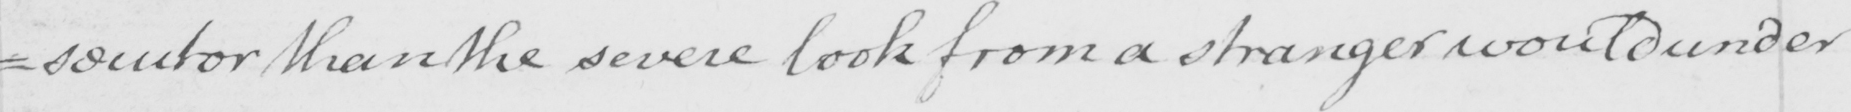What does this handwritten line say? =secutor than the severe look from a stranger would under 